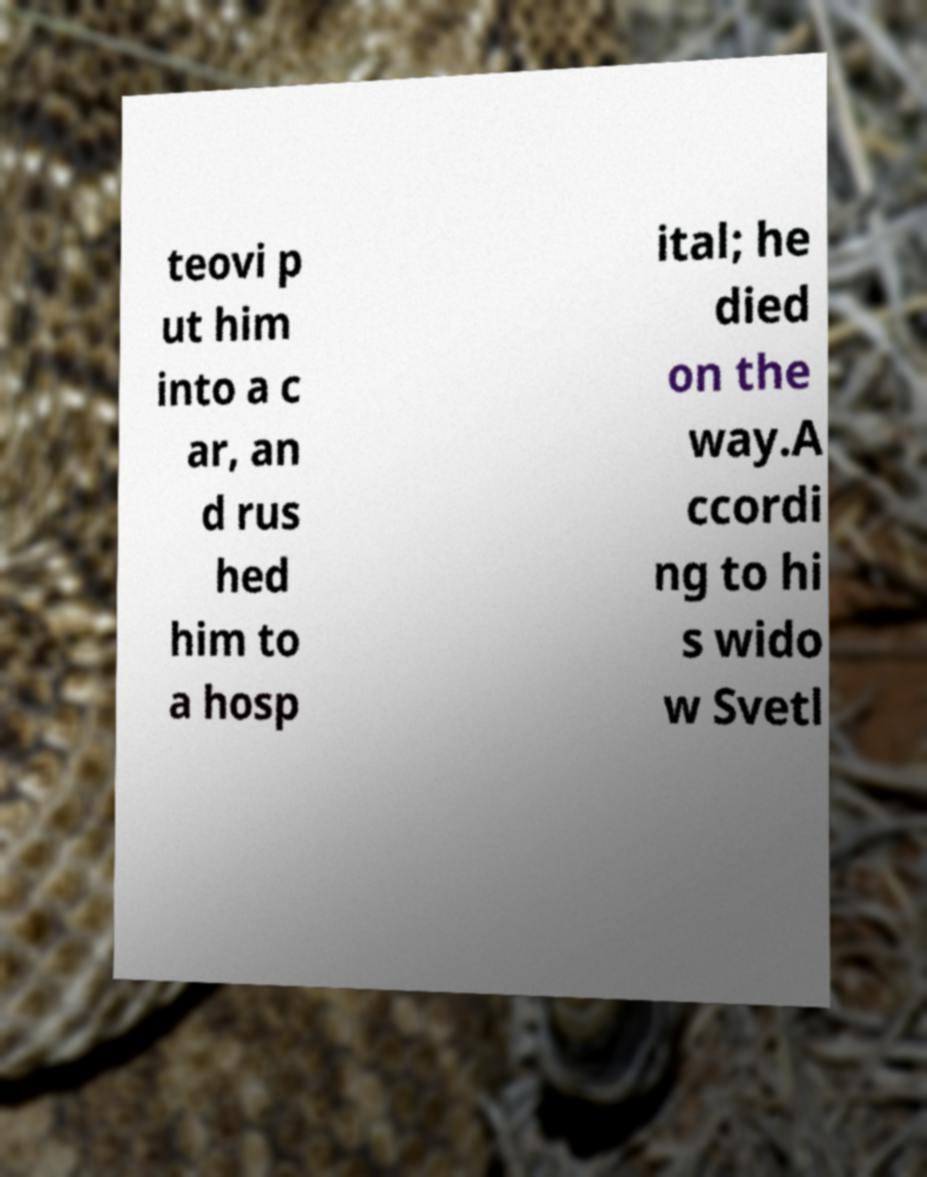What messages or text are displayed in this image? I need them in a readable, typed format. teovi p ut him into a c ar, an d rus hed him to a hosp ital; he died on the way.A ccordi ng to hi s wido w Svetl 